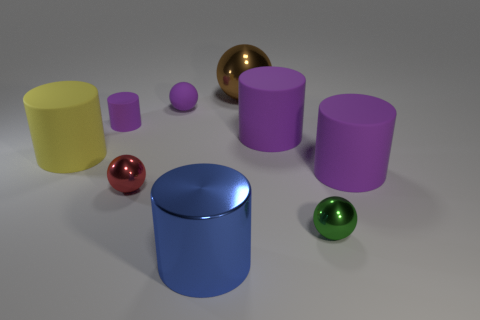There is a tiny cylinder that is the same color as the rubber sphere; what material is it?
Offer a very short reply. Rubber. Is the number of green objects that are in front of the large blue object the same as the number of small metal objects?
Your answer should be very brief. No. There is a small green ball; are there any small purple things in front of it?
Ensure brevity in your answer.  No. How many shiny things are either small cyan cylinders or small cylinders?
Offer a terse response. 0. How many small things are on the right side of the blue metal object?
Offer a terse response. 1. Are there any brown shiny balls of the same size as the green object?
Provide a succinct answer. No. Is there a tiny metal object of the same color as the large sphere?
Your answer should be very brief. No. Are there any other things that have the same size as the yellow cylinder?
Provide a short and direct response. Yes. How many large rubber cylinders are the same color as the small matte cylinder?
Your answer should be very brief. 2. There is a metallic cylinder; is it the same color as the shiny object that is right of the brown sphere?
Give a very brief answer. No. 